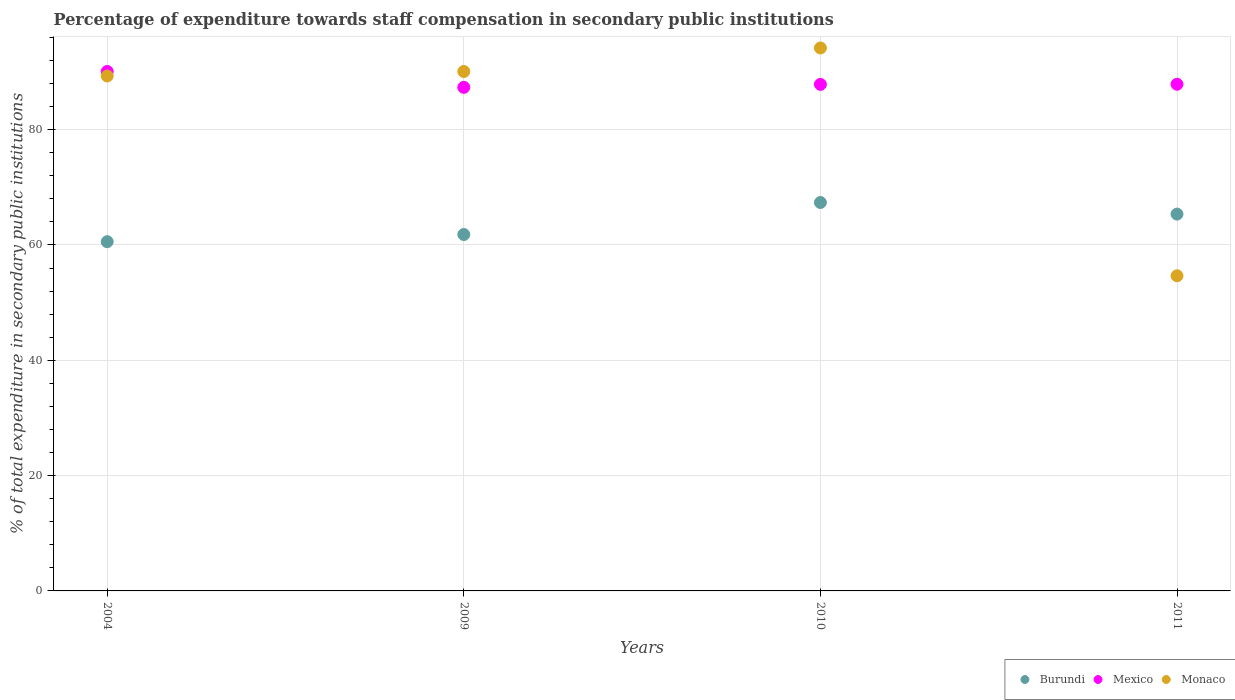How many different coloured dotlines are there?
Your response must be concise. 3. Is the number of dotlines equal to the number of legend labels?
Your answer should be compact. Yes. What is the percentage of expenditure towards staff compensation in Burundi in 2009?
Your answer should be very brief. 61.82. Across all years, what is the maximum percentage of expenditure towards staff compensation in Monaco?
Provide a short and direct response. 94.17. Across all years, what is the minimum percentage of expenditure towards staff compensation in Monaco?
Provide a succinct answer. 54.66. In which year was the percentage of expenditure towards staff compensation in Mexico maximum?
Keep it short and to the point. 2004. What is the total percentage of expenditure towards staff compensation in Monaco in the graph?
Ensure brevity in your answer.  328.22. What is the difference between the percentage of expenditure towards staff compensation in Burundi in 2004 and that in 2011?
Offer a terse response. -4.78. What is the difference between the percentage of expenditure towards staff compensation in Mexico in 2004 and the percentage of expenditure towards staff compensation in Monaco in 2010?
Provide a short and direct response. -4.08. What is the average percentage of expenditure towards staff compensation in Mexico per year?
Provide a short and direct response. 88.29. In the year 2011, what is the difference between the percentage of expenditure towards staff compensation in Monaco and percentage of expenditure towards staff compensation in Mexico?
Offer a terse response. -33.22. In how many years, is the percentage of expenditure towards staff compensation in Monaco greater than 92 %?
Your response must be concise. 1. What is the ratio of the percentage of expenditure towards staff compensation in Mexico in 2004 to that in 2011?
Give a very brief answer. 1.03. What is the difference between the highest and the second highest percentage of expenditure towards staff compensation in Burundi?
Offer a very short reply. 2.01. What is the difference between the highest and the lowest percentage of expenditure towards staff compensation in Mexico?
Your answer should be very brief. 2.75. Is it the case that in every year, the sum of the percentage of expenditure towards staff compensation in Monaco and percentage of expenditure towards staff compensation in Burundi  is greater than the percentage of expenditure towards staff compensation in Mexico?
Keep it short and to the point. Yes. Does the percentage of expenditure towards staff compensation in Monaco monotonically increase over the years?
Make the answer very short. No. Is the percentage of expenditure towards staff compensation in Burundi strictly greater than the percentage of expenditure towards staff compensation in Mexico over the years?
Give a very brief answer. No. How many dotlines are there?
Ensure brevity in your answer.  3. What is the difference between two consecutive major ticks on the Y-axis?
Ensure brevity in your answer.  20. Does the graph contain grids?
Your answer should be very brief. Yes. How many legend labels are there?
Make the answer very short. 3. What is the title of the graph?
Your answer should be very brief. Percentage of expenditure towards staff compensation in secondary public institutions. What is the label or title of the Y-axis?
Your answer should be compact. % of total expenditure in secondary public institutions. What is the % of total expenditure in secondary public institutions in Burundi in 2004?
Your answer should be very brief. 60.57. What is the % of total expenditure in secondary public institutions of Mexico in 2004?
Offer a terse response. 90.09. What is the % of total expenditure in secondary public institutions of Monaco in 2004?
Your response must be concise. 89.31. What is the % of total expenditure in secondary public institutions in Burundi in 2009?
Make the answer very short. 61.82. What is the % of total expenditure in secondary public institutions in Mexico in 2009?
Keep it short and to the point. 87.34. What is the % of total expenditure in secondary public institutions in Monaco in 2009?
Your answer should be compact. 90.09. What is the % of total expenditure in secondary public institutions of Burundi in 2010?
Your response must be concise. 67.37. What is the % of total expenditure in secondary public institutions in Mexico in 2010?
Your response must be concise. 87.85. What is the % of total expenditure in secondary public institutions of Monaco in 2010?
Keep it short and to the point. 94.17. What is the % of total expenditure in secondary public institutions in Burundi in 2011?
Ensure brevity in your answer.  65.36. What is the % of total expenditure in secondary public institutions in Mexico in 2011?
Your answer should be compact. 87.88. What is the % of total expenditure in secondary public institutions in Monaco in 2011?
Provide a succinct answer. 54.66. Across all years, what is the maximum % of total expenditure in secondary public institutions in Burundi?
Offer a very short reply. 67.37. Across all years, what is the maximum % of total expenditure in secondary public institutions in Mexico?
Your response must be concise. 90.09. Across all years, what is the maximum % of total expenditure in secondary public institutions of Monaco?
Give a very brief answer. 94.17. Across all years, what is the minimum % of total expenditure in secondary public institutions of Burundi?
Offer a very short reply. 60.57. Across all years, what is the minimum % of total expenditure in secondary public institutions of Mexico?
Offer a very short reply. 87.34. Across all years, what is the minimum % of total expenditure in secondary public institutions in Monaco?
Provide a succinct answer. 54.66. What is the total % of total expenditure in secondary public institutions in Burundi in the graph?
Make the answer very short. 255.11. What is the total % of total expenditure in secondary public institutions in Mexico in the graph?
Ensure brevity in your answer.  353.16. What is the total % of total expenditure in secondary public institutions in Monaco in the graph?
Your answer should be compact. 328.22. What is the difference between the % of total expenditure in secondary public institutions in Burundi in 2004 and that in 2009?
Your answer should be very brief. -1.24. What is the difference between the % of total expenditure in secondary public institutions of Mexico in 2004 and that in 2009?
Your response must be concise. 2.75. What is the difference between the % of total expenditure in secondary public institutions in Monaco in 2004 and that in 2009?
Give a very brief answer. -0.78. What is the difference between the % of total expenditure in secondary public institutions of Burundi in 2004 and that in 2010?
Your answer should be very brief. -6.79. What is the difference between the % of total expenditure in secondary public institutions of Mexico in 2004 and that in 2010?
Your response must be concise. 2.23. What is the difference between the % of total expenditure in secondary public institutions of Monaco in 2004 and that in 2010?
Your answer should be very brief. -4.86. What is the difference between the % of total expenditure in secondary public institutions of Burundi in 2004 and that in 2011?
Your answer should be very brief. -4.78. What is the difference between the % of total expenditure in secondary public institutions of Mexico in 2004 and that in 2011?
Offer a terse response. 2.21. What is the difference between the % of total expenditure in secondary public institutions in Monaco in 2004 and that in 2011?
Keep it short and to the point. 34.65. What is the difference between the % of total expenditure in secondary public institutions of Burundi in 2009 and that in 2010?
Provide a succinct answer. -5.55. What is the difference between the % of total expenditure in secondary public institutions of Mexico in 2009 and that in 2010?
Offer a very short reply. -0.52. What is the difference between the % of total expenditure in secondary public institutions of Monaco in 2009 and that in 2010?
Offer a very short reply. -4.08. What is the difference between the % of total expenditure in secondary public institutions of Burundi in 2009 and that in 2011?
Your response must be concise. -3.54. What is the difference between the % of total expenditure in secondary public institutions in Mexico in 2009 and that in 2011?
Your answer should be very brief. -0.54. What is the difference between the % of total expenditure in secondary public institutions of Monaco in 2009 and that in 2011?
Provide a succinct answer. 35.43. What is the difference between the % of total expenditure in secondary public institutions of Burundi in 2010 and that in 2011?
Provide a succinct answer. 2.01. What is the difference between the % of total expenditure in secondary public institutions of Mexico in 2010 and that in 2011?
Make the answer very short. -0.02. What is the difference between the % of total expenditure in secondary public institutions in Monaco in 2010 and that in 2011?
Offer a terse response. 39.51. What is the difference between the % of total expenditure in secondary public institutions of Burundi in 2004 and the % of total expenditure in secondary public institutions of Mexico in 2009?
Your response must be concise. -26.77. What is the difference between the % of total expenditure in secondary public institutions of Burundi in 2004 and the % of total expenditure in secondary public institutions of Monaco in 2009?
Offer a very short reply. -29.52. What is the difference between the % of total expenditure in secondary public institutions of Mexico in 2004 and the % of total expenditure in secondary public institutions of Monaco in 2009?
Provide a short and direct response. -0. What is the difference between the % of total expenditure in secondary public institutions of Burundi in 2004 and the % of total expenditure in secondary public institutions of Mexico in 2010?
Offer a very short reply. -27.28. What is the difference between the % of total expenditure in secondary public institutions in Burundi in 2004 and the % of total expenditure in secondary public institutions in Monaco in 2010?
Your response must be concise. -33.6. What is the difference between the % of total expenditure in secondary public institutions in Mexico in 2004 and the % of total expenditure in secondary public institutions in Monaco in 2010?
Your answer should be very brief. -4.08. What is the difference between the % of total expenditure in secondary public institutions of Burundi in 2004 and the % of total expenditure in secondary public institutions of Mexico in 2011?
Your answer should be compact. -27.31. What is the difference between the % of total expenditure in secondary public institutions of Burundi in 2004 and the % of total expenditure in secondary public institutions of Monaco in 2011?
Provide a short and direct response. 5.92. What is the difference between the % of total expenditure in secondary public institutions in Mexico in 2004 and the % of total expenditure in secondary public institutions in Monaco in 2011?
Keep it short and to the point. 35.43. What is the difference between the % of total expenditure in secondary public institutions in Burundi in 2009 and the % of total expenditure in secondary public institutions in Mexico in 2010?
Your answer should be very brief. -26.04. What is the difference between the % of total expenditure in secondary public institutions in Burundi in 2009 and the % of total expenditure in secondary public institutions in Monaco in 2010?
Your answer should be compact. -32.35. What is the difference between the % of total expenditure in secondary public institutions of Mexico in 2009 and the % of total expenditure in secondary public institutions of Monaco in 2010?
Give a very brief answer. -6.83. What is the difference between the % of total expenditure in secondary public institutions of Burundi in 2009 and the % of total expenditure in secondary public institutions of Mexico in 2011?
Make the answer very short. -26.06. What is the difference between the % of total expenditure in secondary public institutions in Burundi in 2009 and the % of total expenditure in secondary public institutions in Monaco in 2011?
Offer a terse response. 7.16. What is the difference between the % of total expenditure in secondary public institutions of Mexico in 2009 and the % of total expenditure in secondary public institutions of Monaco in 2011?
Provide a succinct answer. 32.68. What is the difference between the % of total expenditure in secondary public institutions of Burundi in 2010 and the % of total expenditure in secondary public institutions of Mexico in 2011?
Offer a very short reply. -20.51. What is the difference between the % of total expenditure in secondary public institutions of Burundi in 2010 and the % of total expenditure in secondary public institutions of Monaco in 2011?
Make the answer very short. 12.71. What is the difference between the % of total expenditure in secondary public institutions in Mexico in 2010 and the % of total expenditure in secondary public institutions in Monaco in 2011?
Make the answer very short. 33.2. What is the average % of total expenditure in secondary public institutions of Burundi per year?
Ensure brevity in your answer.  63.78. What is the average % of total expenditure in secondary public institutions of Mexico per year?
Offer a very short reply. 88.29. What is the average % of total expenditure in secondary public institutions of Monaco per year?
Your answer should be compact. 82.06. In the year 2004, what is the difference between the % of total expenditure in secondary public institutions of Burundi and % of total expenditure in secondary public institutions of Mexico?
Give a very brief answer. -29.52. In the year 2004, what is the difference between the % of total expenditure in secondary public institutions of Burundi and % of total expenditure in secondary public institutions of Monaco?
Your response must be concise. -28.74. In the year 2004, what is the difference between the % of total expenditure in secondary public institutions of Mexico and % of total expenditure in secondary public institutions of Monaco?
Your answer should be compact. 0.78. In the year 2009, what is the difference between the % of total expenditure in secondary public institutions of Burundi and % of total expenditure in secondary public institutions of Mexico?
Keep it short and to the point. -25.52. In the year 2009, what is the difference between the % of total expenditure in secondary public institutions in Burundi and % of total expenditure in secondary public institutions in Monaco?
Offer a terse response. -28.27. In the year 2009, what is the difference between the % of total expenditure in secondary public institutions in Mexico and % of total expenditure in secondary public institutions in Monaco?
Offer a very short reply. -2.75. In the year 2010, what is the difference between the % of total expenditure in secondary public institutions in Burundi and % of total expenditure in secondary public institutions in Mexico?
Your response must be concise. -20.49. In the year 2010, what is the difference between the % of total expenditure in secondary public institutions in Burundi and % of total expenditure in secondary public institutions in Monaco?
Your answer should be compact. -26.8. In the year 2010, what is the difference between the % of total expenditure in secondary public institutions of Mexico and % of total expenditure in secondary public institutions of Monaco?
Your response must be concise. -6.32. In the year 2011, what is the difference between the % of total expenditure in secondary public institutions in Burundi and % of total expenditure in secondary public institutions in Mexico?
Your answer should be very brief. -22.52. In the year 2011, what is the difference between the % of total expenditure in secondary public institutions of Burundi and % of total expenditure in secondary public institutions of Monaco?
Give a very brief answer. 10.7. In the year 2011, what is the difference between the % of total expenditure in secondary public institutions of Mexico and % of total expenditure in secondary public institutions of Monaco?
Give a very brief answer. 33.22. What is the ratio of the % of total expenditure in secondary public institutions in Burundi in 2004 to that in 2009?
Provide a short and direct response. 0.98. What is the ratio of the % of total expenditure in secondary public institutions in Mexico in 2004 to that in 2009?
Keep it short and to the point. 1.03. What is the ratio of the % of total expenditure in secondary public institutions of Burundi in 2004 to that in 2010?
Your answer should be very brief. 0.9. What is the ratio of the % of total expenditure in secondary public institutions of Mexico in 2004 to that in 2010?
Offer a terse response. 1.03. What is the ratio of the % of total expenditure in secondary public institutions in Monaco in 2004 to that in 2010?
Keep it short and to the point. 0.95. What is the ratio of the % of total expenditure in secondary public institutions of Burundi in 2004 to that in 2011?
Offer a terse response. 0.93. What is the ratio of the % of total expenditure in secondary public institutions of Mexico in 2004 to that in 2011?
Make the answer very short. 1.03. What is the ratio of the % of total expenditure in secondary public institutions of Monaco in 2004 to that in 2011?
Your response must be concise. 1.63. What is the ratio of the % of total expenditure in secondary public institutions of Burundi in 2009 to that in 2010?
Your answer should be compact. 0.92. What is the ratio of the % of total expenditure in secondary public institutions in Mexico in 2009 to that in 2010?
Give a very brief answer. 0.99. What is the ratio of the % of total expenditure in secondary public institutions in Monaco in 2009 to that in 2010?
Offer a terse response. 0.96. What is the ratio of the % of total expenditure in secondary public institutions of Burundi in 2009 to that in 2011?
Provide a short and direct response. 0.95. What is the ratio of the % of total expenditure in secondary public institutions of Mexico in 2009 to that in 2011?
Offer a terse response. 0.99. What is the ratio of the % of total expenditure in secondary public institutions in Monaco in 2009 to that in 2011?
Your response must be concise. 1.65. What is the ratio of the % of total expenditure in secondary public institutions of Burundi in 2010 to that in 2011?
Offer a terse response. 1.03. What is the ratio of the % of total expenditure in secondary public institutions of Monaco in 2010 to that in 2011?
Your response must be concise. 1.72. What is the difference between the highest and the second highest % of total expenditure in secondary public institutions in Burundi?
Ensure brevity in your answer.  2.01. What is the difference between the highest and the second highest % of total expenditure in secondary public institutions in Mexico?
Keep it short and to the point. 2.21. What is the difference between the highest and the second highest % of total expenditure in secondary public institutions of Monaco?
Ensure brevity in your answer.  4.08. What is the difference between the highest and the lowest % of total expenditure in secondary public institutions in Burundi?
Offer a very short reply. 6.79. What is the difference between the highest and the lowest % of total expenditure in secondary public institutions of Mexico?
Offer a very short reply. 2.75. What is the difference between the highest and the lowest % of total expenditure in secondary public institutions in Monaco?
Your answer should be compact. 39.51. 